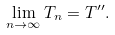<formula> <loc_0><loc_0><loc_500><loc_500>\lim _ { n \rightarrow \infty } T _ { n } = T ^ { \prime \prime } .</formula> 